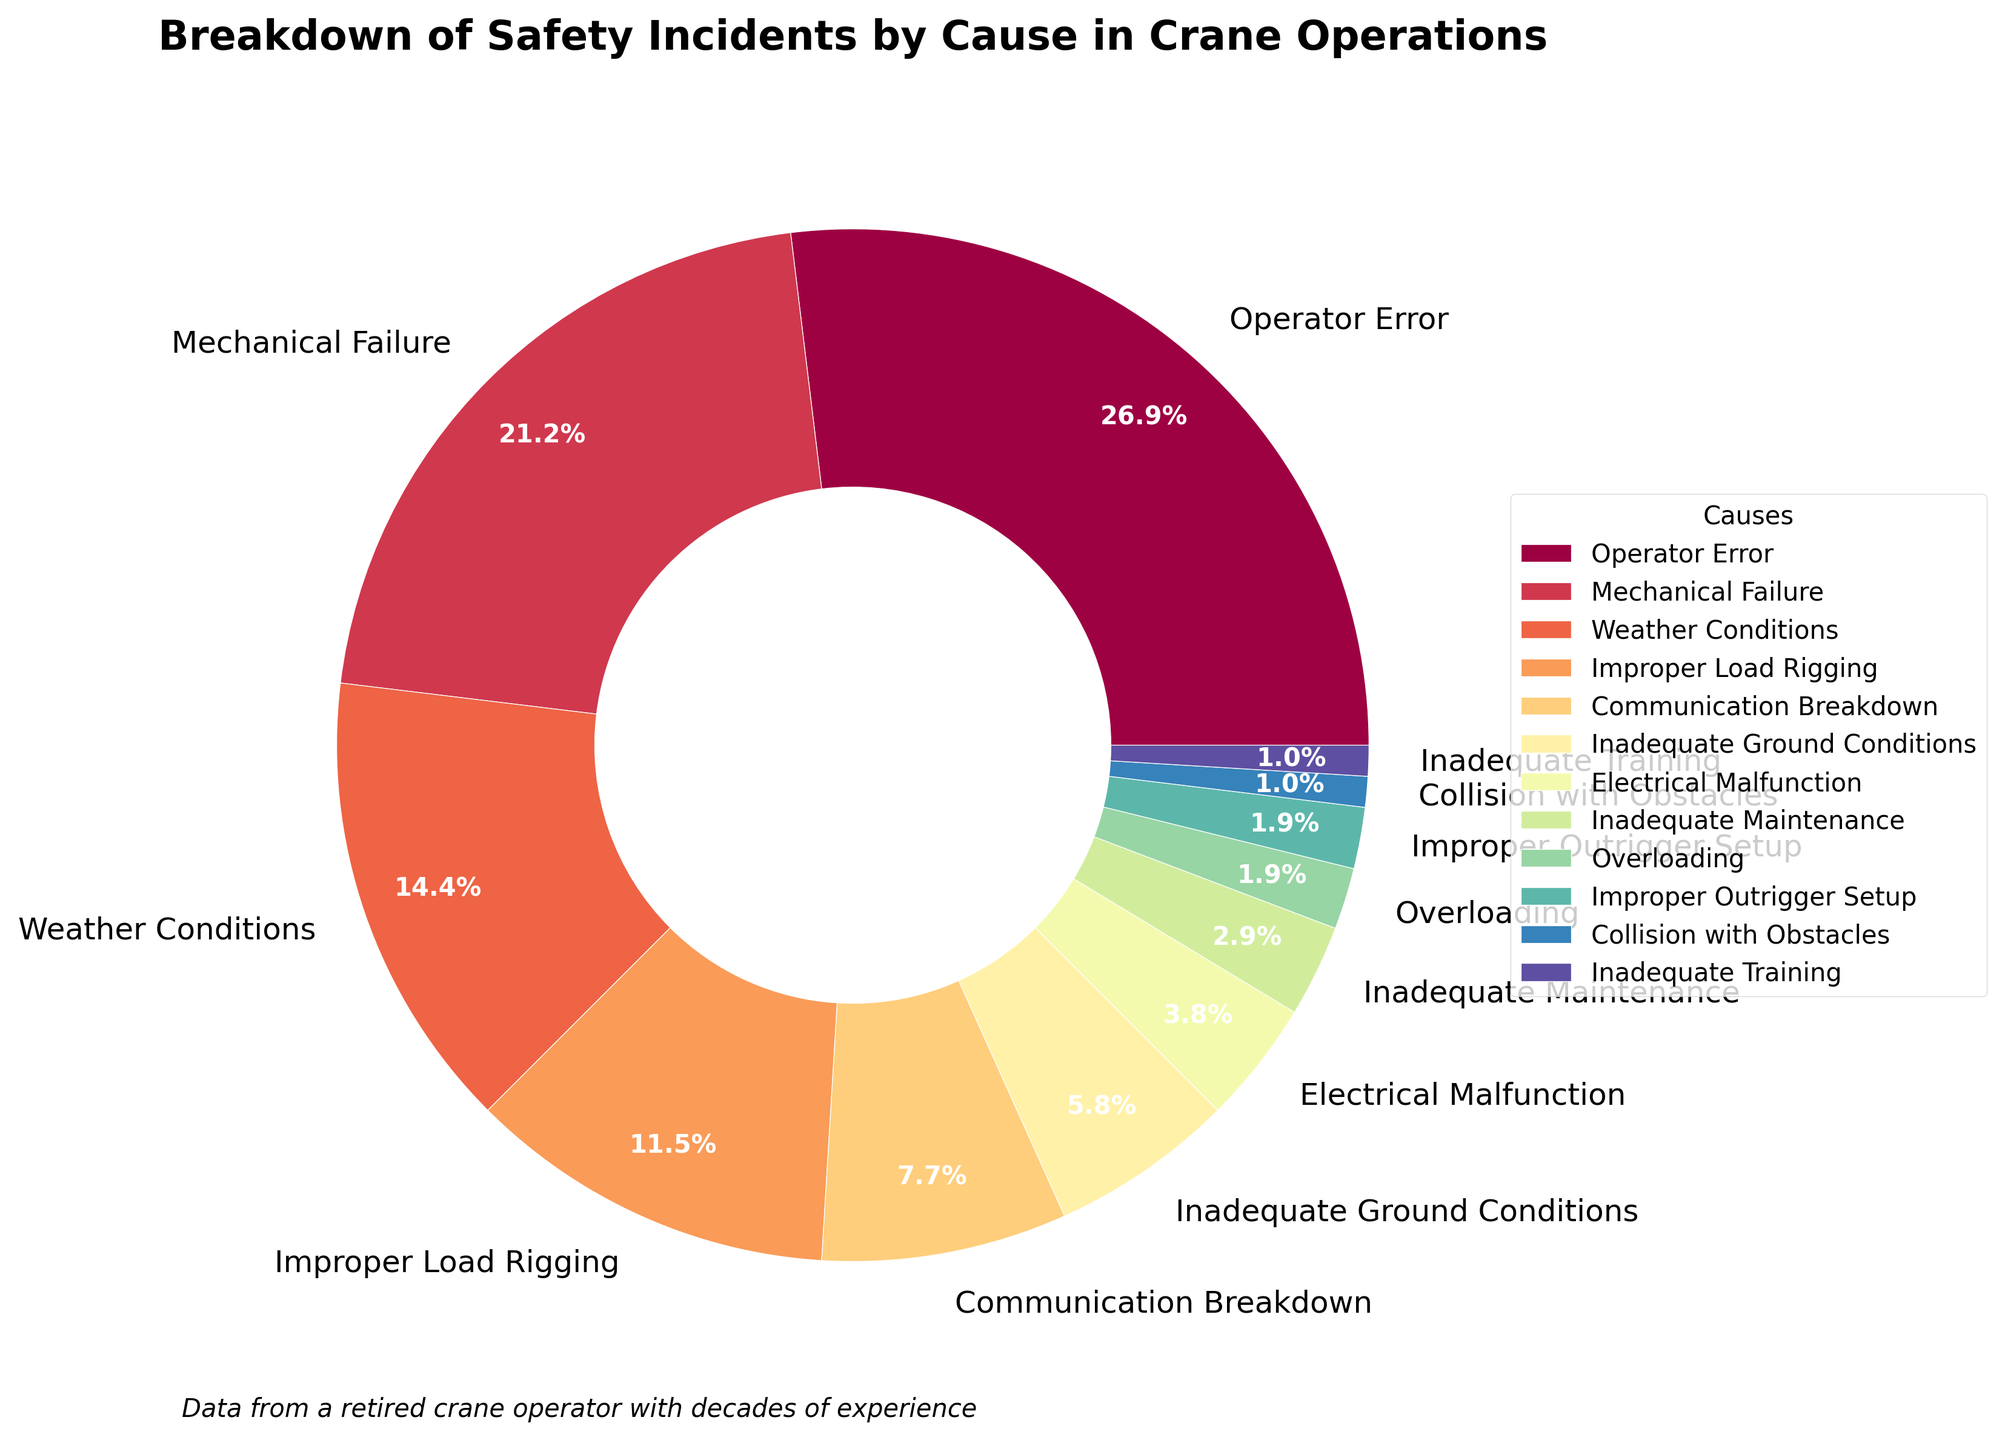What's the most common cause of safety incidents in crane operations? The most common cause is the one with the highest percentage. According to the figure, the segment labeled "Operator Error" has the largest percentage.
Answer: Operator Error Which cause has the smallest percentage? The segment with the smallest percentage represents the least common cause. According to the figure, "Collision with Obstacles" and "Inadequate Training" both have the lowest percentage at 1% each.
Answer: Collision with Obstacles and Inadequate Training By how much does Operator Error exceed Mechanical Failure in terms of safety incidents percentage? To find the difference, subtract the percentage of Mechanical Failure from that of Operator Error: 28% (Operator Error) - 22% (Mechanical Failure).
Answer: 6% What is the combined percentage of incidents caused by Weather Conditions, Improper Load Rigging, and Communication Breakdown? Add the percentages for Weather Conditions (15%), Improper Load Rigging (12%), and Communication Breakdown (8%): 15% + 12% + 8%.
Answer: 35% Are there more incidents caused by Mechanical Failure or by Improper Load Rigging and Inadequate Ground Conditions combined? Compare the percentage for Mechanical Failure (22%) with the combined percentage of Improper Load Rigging (12%) and Inadequate Ground Conditions (6%): 12% + 6% = 18%. Since 22% > 18%, Mechanical Failure causes more incidents.
Answer: Mechanical Failure Which causes together make up a percentage greater than that of Weather Conditions alone? Identify groups of causes whose combined percentage is greater than that of Weather Conditions (15%). For example, Inadequate Ground Conditions (6%) and Communication Breakdown (8%) together make 6% + 8% = 14%, which is less, but adding Improper Load Rigging (12%) gives 14% + 12% = 26%, which is greater. So Improper Load Rigging and any combination of smaller causes exceeding 3% would work.
Answer: Improper Load Rigging and any smaller causes sum greater than 3% How does the pie chart visually distinguish different causes? The pie chart uses distinct colors for each segment to represent different causes. The colors are chosen from a varied color map to ensure each cause is visually separated and easily identifiable. Also, the segments are labeled with their respective percentages.
Answer: Distinct colors and percentage labels 